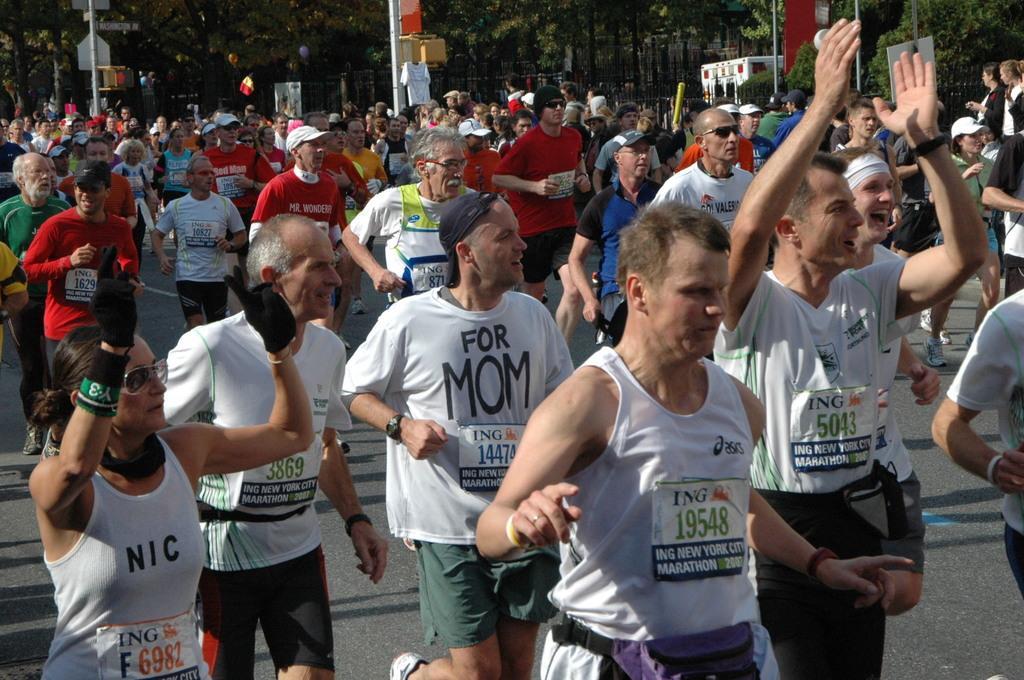In one or two sentences, can you explain what this image depicts? In this picture I can see so many people are running on the road, side of the road we can see trees and poles. 